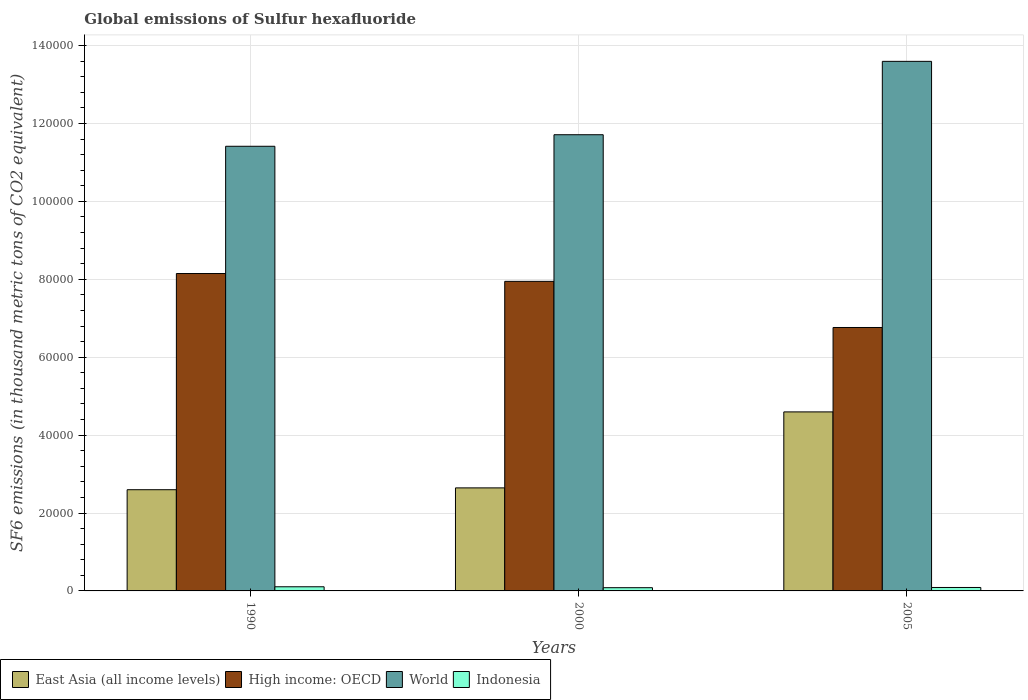How many different coloured bars are there?
Offer a very short reply. 4. Are the number of bars per tick equal to the number of legend labels?
Make the answer very short. Yes. How many bars are there on the 1st tick from the left?
Ensure brevity in your answer.  4. How many bars are there on the 1st tick from the right?
Keep it short and to the point. 4. In how many cases, is the number of bars for a given year not equal to the number of legend labels?
Keep it short and to the point. 0. What is the global emissions of Sulfur hexafluoride in Indonesia in 1990?
Make the answer very short. 1062.8. Across all years, what is the maximum global emissions of Sulfur hexafluoride in East Asia (all income levels)?
Your answer should be compact. 4.60e+04. Across all years, what is the minimum global emissions of Sulfur hexafluoride in Indonesia?
Your answer should be very brief. 826.8. In which year was the global emissions of Sulfur hexafluoride in High income: OECD minimum?
Make the answer very short. 2005. What is the total global emissions of Sulfur hexafluoride in High income: OECD in the graph?
Ensure brevity in your answer.  2.29e+05. What is the difference between the global emissions of Sulfur hexafluoride in Indonesia in 1990 and that in 2000?
Provide a succinct answer. 236. What is the difference between the global emissions of Sulfur hexafluoride in East Asia (all income levels) in 2000 and the global emissions of Sulfur hexafluoride in World in 2005?
Ensure brevity in your answer.  -1.09e+05. What is the average global emissions of Sulfur hexafluoride in High income: OECD per year?
Your response must be concise. 7.62e+04. In the year 2005, what is the difference between the global emissions of Sulfur hexafluoride in High income: OECD and global emissions of Sulfur hexafluoride in East Asia (all income levels)?
Provide a short and direct response. 2.17e+04. What is the ratio of the global emissions of Sulfur hexafluoride in Indonesia in 1990 to that in 2005?
Give a very brief answer. 1.2. Is the global emissions of Sulfur hexafluoride in East Asia (all income levels) in 2000 less than that in 2005?
Provide a succinct answer. Yes. What is the difference between the highest and the second highest global emissions of Sulfur hexafluoride in World?
Ensure brevity in your answer.  1.88e+04. What is the difference between the highest and the lowest global emissions of Sulfur hexafluoride in East Asia (all income levels)?
Provide a succinct answer. 2.00e+04. In how many years, is the global emissions of Sulfur hexafluoride in World greater than the average global emissions of Sulfur hexafluoride in World taken over all years?
Give a very brief answer. 1. What does the 3rd bar from the left in 2000 represents?
Give a very brief answer. World. Is it the case that in every year, the sum of the global emissions of Sulfur hexafluoride in High income: OECD and global emissions of Sulfur hexafluoride in Indonesia is greater than the global emissions of Sulfur hexafluoride in East Asia (all income levels)?
Give a very brief answer. Yes. How many bars are there?
Offer a terse response. 12. Are the values on the major ticks of Y-axis written in scientific E-notation?
Your response must be concise. No. Does the graph contain any zero values?
Keep it short and to the point. No. Does the graph contain grids?
Keep it short and to the point. Yes. How many legend labels are there?
Keep it short and to the point. 4. What is the title of the graph?
Provide a short and direct response. Global emissions of Sulfur hexafluoride. What is the label or title of the Y-axis?
Provide a short and direct response. SF6 emissions (in thousand metric tons of CO2 equivalent). What is the SF6 emissions (in thousand metric tons of CO2 equivalent) of East Asia (all income levels) in 1990?
Provide a succinct answer. 2.60e+04. What is the SF6 emissions (in thousand metric tons of CO2 equivalent) of High income: OECD in 1990?
Provide a succinct answer. 8.15e+04. What is the SF6 emissions (in thousand metric tons of CO2 equivalent) of World in 1990?
Provide a succinct answer. 1.14e+05. What is the SF6 emissions (in thousand metric tons of CO2 equivalent) of Indonesia in 1990?
Offer a terse response. 1062.8. What is the SF6 emissions (in thousand metric tons of CO2 equivalent) in East Asia (all income levels) in 2000?
Keep it short and to the point. 2.65e+04. What is the SF6 emissions (in thousand metric tons of CO2 equivalent) of High income: OECD in 2000?
Provide a short and direct response. 7.95e+04. What is the SF6 emissions (in thousand metric tons of CO2 equivalent) of World in 2000?
Your answer should be very brief. 1.17e+05. What is the SF6 emissions (in thousand metric tons of CO2 equivalent) in Indonesia in 2000?
Ensure brevity in your answer.  826.8. What is the SF6 emissions (in thousand metric tons of CO2 equivalent) of East Asia (all income levels) in 2005?
Your answer should be compact. 4.60e+04. What is the SF6 emissions (in thousand metric tons of CO2 equivalent) in High income: OECD in 2005?
Your answer should be very brief. 6.76e+04. What is the SF6 emissions (in thousand metric tons of CO2 equivalent) of World in 2005?
Ensure brevity in your answer.  1.36e+05. What is the SF6 emissions (in thousand metric tons of CO2 equivalent) in Indonesia in 2005?
Your answer should be very brief. 886.1. Across all years, what is the maximum SF6 emissions (in thousand metric tons of CO2 equivalent) in East Asia (all income levels)?
Keep it short and to the point. 4.60e+04. Across all years, what is the maximum SF6 emissions (in thousand metric tons of CO2 equivalent) in High income: OECD?
Make the answer very short. 8.15e+04. Across all years, what is the maximum SF6 emissions (in thousand metric tons of CO2 equivalent) in World?
Your answer should be compact. 1.36e+05. Across all years, what is the maximum SF6 emissions (in thousand metric tons of CO2 equivalent) of Indonesia?
Keep it short and to the point. 1062.8. Across all years, what is the minimum SF6 emissions (in thousand metric tons of CO2 equivalent) of East Asia (all income levels)?
Ensure brevity in your answer.  2.60e+04. Across all years, what is the minimum SF6 emissions (in thousand metric tons of CO2 equivalent) of High income: OECD?
Provide a short and direct response. 6.76e+04. Across all years, what is the minimum SF6 emissions (in thousand metric tons of CO2 equivalent) in World?
Offer a very short reply. 1.14e+05. Across all years, what is the minimum SF6 emissions (in thousand metric tons of CO2 equivalent) of Indonesia?
Give a very brief answer. 826.8. What is the total SF6 emissions (in thousand metric tons of CO2 equivalent) of East Asia (all income levels) in the graph?
Keep it short and to the point. 9.84e+04. What is the total SF6 emissions (in thousand metric tons of CO2 equivalent) of High income: OECD in the graph?
Your response must be concise. 2.29e+05. What is the total SF6 emissions (in thousand metric tons of CO2 equivalent) in World in the graph?
Ensure brevity in your answer.  3.67e+05. What is the total SF6 emissions (in thousand metric tons of CO2 equivalent) of Indonesia in the graph?
Keep it short and to the point. 2775.7. What is the difference between the SF6 emissions (in thousand metric tons of CO2 equivalent) in East Asia (all income levels) in 1990 and that in 2000?
Offer a very short reply. -471.9. What is the difference between the SF6 emissions (in thousand metric tons of CO2 equivalent) in High income: OECD in 1990 and that in 2000?
Provide a short and direct response. 2011.1. What is the difference between the SF6 emissions (in thousand metric tons of CO2 equivalent) of World in 1990 and that in 2000?
Your response must be concise. -2964.6. What is the difference between the SF6 emissions (in thousand metric tons of CO2 equivalent) of Indonesia in 1990 and that in 2000?
Your response must be concise. 236. What is the difference between the SF6 emissions (in thousand metric tons of CO2 equivalent) in East Asia (all income levels) in 1990 and that in 2005?
Your answer should be compact. -2.00e+04. What is the difference between the SF6 emissions (in thousand metric tons of CO2 equivalent) in High income: OECD in 1990 and that in 2005?
Make the answer very short. 1.39e+04. What is the difference between the SF6 emissions (in thousand metric tons of CO2 equivalent) in World in 1990 and that in 2005?
Offer a very short reply. -2.18e+04. What is the difference between the SF6 emissions (in thousand metric tons of CO2 equivalent) in Indonesia in 1990 and that in 2005?
Make the answer very short. 176.7. What is the difference between the SF6 emissions (in thousand metric tons of CO2 equivalent) of East Asia (all income levels) in 2000 and that in 2005?
Keep it short and to the point. -1.95e+04. What is the difference between the SF6 emissions (in thousand metric tons of CO2 equivalent) in High income: OECD in 2000 and that in 2005?
Offer a terse response. 1.18e+04. What is the difference between the SF6 emissions (in thousand metric tons of CO2 equivalent) of World in 2000 and that in 2005?
Provide a succinct answer. -1.88e+04. What is the difference between the SF6 emissions (in thousand metric tons of CO2 equivalent) of Indonesia in 2000 and that in 2005?
Your answer should be very brief. -59.3. What is the difference between the SF6 emissions (in thousand metric tons of CO2 equivalent) in East Asia (all income levels) in 1990 and the SF6 emissions (in thousand metric tons of CO2 equivalent) in High income: OECD in 2000?
Your answer should be very brief. -5.35e+04. What is the difference between the SF6 emissions (in thousand metric tons of CO2 equivalent) in East Asia (all income levels) in 1990 and the SF6 emissions (in thousand metric tons of CO2 equivalent) in World in 2000?
Your answer should be very brief. -9.11e+04. What is the difference between the SF6 emissions (in thousand metric tons of CO2 equivalent) of East Asia (all income levels) in 1990 and the SF6 emissions (in thousand metric tons of CO2 equivalent) of Indonesia in 2000?
Your answer should be very brief. 2.52e+04. What is the difference between the SF6 emissions (in thousand metric tons of CO2 equivalent) of High income: OECD in 1990 and the SF6 emissions (in thousand metric tons of CO2 equivalent) of World in 2000?
Ensure brevity in your answer.  -3.56e+04. What is the difference between the SF6 emissions (in thousand metric tons of CO2 equivalent) of High income: OECD in 1990 and the SF6 emissions (in thousand metric tons of CO2 equivalent) of Indonesia in 2000?
Your answer should be very brief. 8.06e+04. What is the difference between the SF6 emissions (in thousand metric tons of CO2 equivalent) in World in 1990 and the SF6 emissions (in thousand metric tons of CO2 equivalent) in Indonesia in 2000?
Your response must be concise. 1.13e+05. What is the difference between the SF6 emissions (in thousand metric tons of CO2 equivalent) in East Asia (all income levels) in 1990 and the SF6 emissions (in thousand metric tons of CO2 equivalent) in High income: OECD in 2005?
Provide a short and direct response. -4.16e+04. What is the difference between the SF6 emissions (in thousand metric tons of CO2 equivalent) of East Asia (all income levels) in 1990 and the SF6 emissions (in thousand metric tons of CO2 equivalent) of World in 2005?
Your answer should be very brief. -1.10e+05. What is the difference between the SF6 emissions (in thousand metric tons of CO2 equivalent) of East Asia (all income levels) in 1990 and the SF6 emissions (in thousand metric tons of CO2 equivalent) of Indonesia in 2005?
Offer a terse response. 2.51e+04. What is the difference between the SF6 emissions (in thousand metric tons of CO2 equivalent) of High income: OECD in 1990 and the SF6 emissions (in thousand metric tons of CO2 equivalent) of World in 2005?
Your answer should be very brief. -5.45e+04. What is the difference between the SF6 emissions (in thousand metric tons of CO2 equivalent) of High income: OECD in 1990 and the SF6 emissions (in thousand metric tons of CO2 equivalent) of Indonesia in 2005?
Make the answer very short. 8.06e+04. What is the difference between the SF6 emissions (in thousand metric tons of CO2 equivalent) in World in 1990 and the SF6 emissions (in thousand metric tons of CO2 equivalent) in Indonesia in 2005?
Make the answer very short. 1.13e+05. What is the difference between the SF6 emissions (in thousand metric tons of CO2 equivalent) of East Asia (all income levels) in 2000 and the SF6 emissions (in thousand metric tons of CO2 equivalent) of High income: OECD in 2005?
Give a very brief answer. -4.12e+04. What is the difference between the SF6 emissions (in thousand metric tons of CO2 equivalent) in East Asia (all income levels) in 2000 and the SF6 emissions (in thousand metric tons of CO2 equivalent) in World in 2005?
Offer a terse response. -1.09e+05. What is the difference between the SF6 emissions (in thousand metric tons of CO2 equivalent) of East Asia (all income levels) in 2000 and the SF6 emissions (in thousand metric tons of CO2 equivalent) of Indonesia in 2005?
Ensure brevity in your answer.  2.56e+04. What is the difference between the SF6 emissions (in thousand metric tons of CO2 equivalent) of High income: OECD in 2000 and the SF6 emissions (in thousand metric tons of CO2 equivalent) of World in 2005?
Provide a short and direct response. -5.65e+04. What is the difference between the SF6 emissions (in thousand metric tons of CO2 equivalent) of High income: OECD in 2000 and the SF6 emissions (in thousand metric tons of CO2 equivalent) of Indonesia in 2005?
Provide a succinct answer. 7.86e+04. What is the difference between the SF6 emissions (in thousand metric tons of CO2 equivalent) in World in 2000 and the SF6 emissions (in thousand metric tons of CO2 equivalent) in Indonesia in 2005?
Give a very brief answer. 1.16e+05. What is the average SF6 emissions (in thousand metric tons of CO2 equivalent) in East Asia (all income levels) per year?
Give a very brief answer. 3.28e+04. What is the average SF6 emissions (in thousand metric tons of CO2 equivalent) in High income: OECD per year?
Provide a succinct answer. 7.62e+04. What is the average SF6 emissions (in thousand metric tons of CO2 equivalent) in World per year?
Your answer should be very brief. 1.22e+05. What is the average SF6 emissions (in thousand metric tons of CO2 equivalent) in Indonesia per year?
Give a very brief answer. 925.23. In the year 1990, what is the difference between the SF6 emissions (in thousand metric tons of CO2 equivalent) in East Asia (all income levels) and SF6 emissions (in thousand metric tons of CO2 equivalent) in High income: OECD?
Offer a very short reply. -5.55e+04. In the year 1990, what is the difference between the SF6 emissions (in thousand metric tons of CO2 equivalent) in East Asia (all income levels) and SF6 emissions (in thousand metric tons of CO2 equivalent) in World?
Provide a short and direct response. -8.82e+04. In the year 1990, what is the difference between the SF6 emissions (in thousand metric tons of CO2 equivalent) in East Asia (all income levels) and SF6 emissions (in thousand metric tons of CO2 equivalent) in Indonesia?
Provide a succinct answer. 2.49e+04. In the year 1990, what is the difference between the SF6 emissions (in thousand metric tons of CO2 equivalent) in High income: OECD and SF6 emissions (in thousand metric tons of CO2 equivalent) in World?
Offer a terse response. -3.27e+04. In the year 1990, what is the difference between the SF6 emissions (in thousand metric tons of CO2 equivalent) of High income: OECD and SF6 emissions (in thousand metric tons of CO2 equivalent) of Indonesia?
Offer a very short reply. 8.04e+04. In the year 1990, what is the difference between the SF6 emissions (in thousand metric tons of CO2 equivalent) in World and SF6 emissions (in thousand metric tons of CO2 equivalent) in Indonesia?
Ensure brevity in your answer.  1.13e+05. In the year 2000, what is the difference between the SF6 emissions (in thousand metric tons of CO2 equivalent) of East Asia (all income levels) and SF6 emissions (in thousand metric tons of CO2 equivalent) of High income: OECD?
Your answer should be compact. -5.30e+04. In the year 2000, what is the difference between the SF6 emissions (in thousand metric tons of CO2 equivalent) in East Asia (all income levels) and SF6 emissions (in thousand metric tons of CO2 equivalent) in World?
Offer a terse response. -9.07e+04. In the year 2000, what is the difference between the SF6 emissions (in thousand metric tons of CO2 equivalent) of East Asia (all income levels) and SF6 emissions (in thousand metric tons of CO2 equivalent) of Indonesia?
Keep it short and to the point. 2.56e+04. In the year 2000, what is the difference between the SF6 emissions (in thousand metric tons of CO2 equivalent) of High income: OECD and SF6 emissions (in thousand metric tons of CO2 equivalent) of World?
Make the answer very short. -3.76e+04. In the year 2000, what is the difference between the SF6 emissions (in thousand metric tons of CO2 equivalent) of High income: OECD and SF6 emissions (in thousand metric tons of CO2 equivalent) of Indonesia?
Ensure brevity in your answer.  7.86e+04. In the year 2000, what is the difference between the SF6 emissions (in thousand metric tons of CO2 equivalent) in World and SF6 emissions (in thousand metric tons of CO2 equivalent) in Indonesia?
Offer a very short reply. 1.16e+05. In the year 2005, what is the difference between the SF6 emissions (in thousand metric tons of CO2 equivalent) in East Asia (all income levels) and SF6 emissions (in thousand metric tons of CO2 equivalent) in High income: OECD?
Keep it short and to the point. -2.17e+04. In the year 2005, what is the difference between the SF6 emissions (in thousand metric tons of CO2 equivalent) of East Asia (all income levels) and SF6 emissions (in thousand metric tons of CO2 equivalent) of World?
Provide a short and direct response. -9.00e+04. In the year 2005, what is the difference between the SF6 emissions (in thousand metric tons of CO2 equivalent) of East Asia (all income levels) and SF6 emissions (in thousand metric tons of CO2 equivalent) of Indonesia?
Your answer should be compact. 4.51e+04. In the year 2005, what is the difference between the SF6 emissions (in thousand metric tons of CO2 equivalent) in High income: OECD and SF6 emissions (in thousand metric tons of CO2 equivalent) in World?
Provide a succinct answer. -6.83e+04. In the year 2005, what is the difference between the SF6 emissions (in thousand metric tons of CO2 equivalent) of High income: OECD and SF6 emissions (in thousand metric tons of CO2 equivalent) of Indonesia?
Provide a succinct answer. 6.67e+04. In the year 2005, what is the difference between the SF6 emissions (in thousand metric tons of CO2 equivalent) of World and SF6 emissions (in thousand metric tons of CO2 equivalent) of Indonesia?
Keep it short and to the point. 1.35e+05. What is the ratio of the SF6 emissions (in thousand metric tons of CO2 equivalent) in East Asia (all income levels) in 1990 to that in 2000?
Make the answer very short. 0.98. What is the ratio of the SF6 emissions (in thousand metric tons of CO2 equivalent) of High income: OECD in 1990 to that in 2000?
Provide a succinct answer. 1.03. What is the ratio of the SF6 emissions (in thousand metric tons of CO2 equivalent) in World in 1990 to that in 2000?
Ensure brevity in your answer.  0.97. What is the ratio of the SF6 emissions (in thousand metric tons of CO2 equivalent) in Indonesia in 1990 to that in 2000?
Give a very brief answer. 1.29. What is the ratio of the SF6 emissions (in thousand metric tons of CO2 equivalent) in East Asia (all income levels) in 1990 to that in 2005?
Give a very brief answer. 0.57. What is the ratio of the SF6 emissions (in thousand metric tons of CO2 equivalent) of High income: OECD in 1990 to that in 2005?
Give a very brief answer. 1.2. What is the ratio of the SF6 emissions (in thousand metric tons of CO2 equivalent) of World in 1990 to that in 2005?
Give a very brief answer. 0.84. What is the ratio of the SF6 emissions (in thousand metric tons of CO2 equivalent) in Indonesia in 1990 to that in 2005?
Offer a terse response. 1.2. What is the ratio of the SF6 emissions (in thousand metric tons of CO2 equivalent) in East Asia (all income levels) in 2000 to that in 2005?
Keep it short and to the point. 0.58. What is the ratio of the SF6 emissions (in thousand metric tons of CO2 equivalent) in High income: OECD in 2000 to that in 2005?
Your answer should be very brief. 1.18. What is the ratio of the SF6 emissions (in thousand metric tons of CO2 equivalent) of World in 2000 to that in 2005?
Offer a terse response. 0.86. What is the ratio of the SF6 emissions (in thousand metric tons of CO2 equivalent) of Indonesia in 2000 to that in 2005?
Keep it short and to the point. 0.93. What is the difference between the highest and the second highest SF6 emissions (in thousand metric tons of CO2 equivalent) of East Asia (all income levels)?
Keep it short and to the point. 1.95e+04. What is the difference between the highest and the second highest SF6 emissions (in thousand metric tons of CO2 equivalent) of High income: OECD?
Ensure brevity in your answer.  2011.1. What is the difference between the highest and the second highest SF6 emissions (in thousand metric tons of CO2 equivalent) in World?
Offer a terse response. 1.88e+04. What is the difference between the highest and the second highest SF6 emissions (in thousand metric tons of CO2 equivalent) of Indonesia?
Your answer should be very brief. 176.7. What is the difference between the highest and the lowest SF6 emissions (in thousand metric tons of CO2 equivalent) in East Asia (all income levels)?
Give a very brief answer. 2.00e+04. What is the difference between the highest and the lowest SF6 emissions (in thousand metric tons of CO2 equivalent) of High income: OECD?
Your answer should be very brief. 1.39e+04. What is the difference between the highest and the lowest SF6 emissions (in thousand metric tons of CO2 equivalent) in World?
Offer a very short reply. 2.18e+04. What is the difference between the highest and the lowest SF6 emissions (in thousand metric tons of CO2 equivalent) of Indonesia?
Your answer should be compact. 236. 